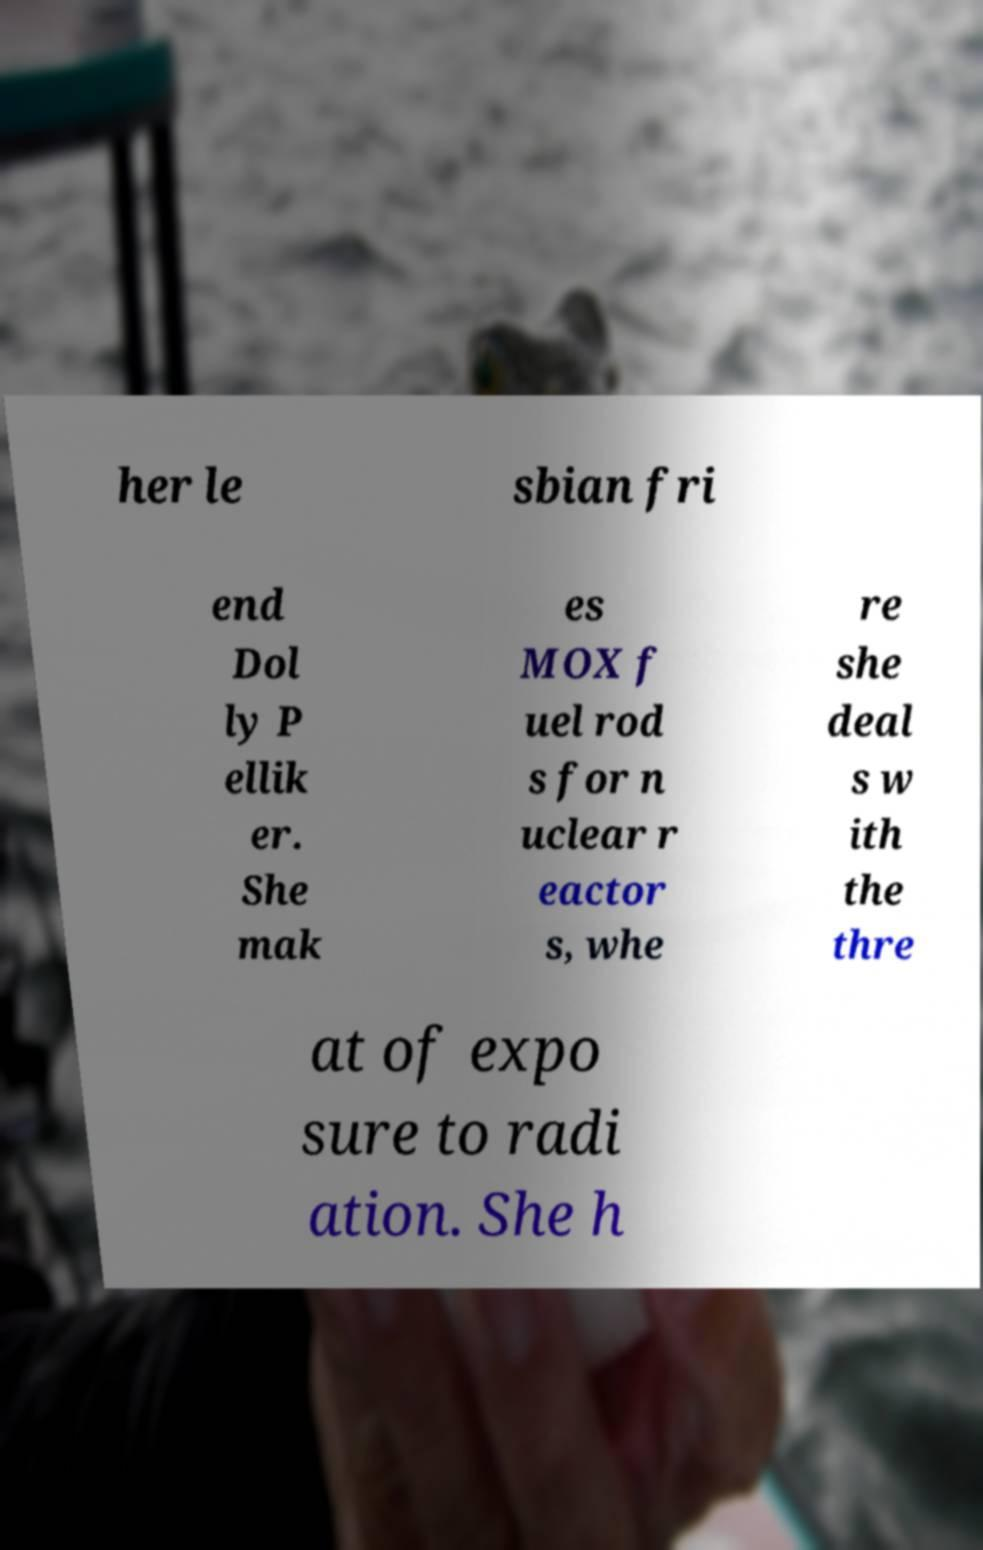Can you accurately transcribe the text from the provided image for me? her le sbian fri end Dol ly P ellik er. She mak es MOX f uel rod s for n uclear r eactor s, whe re she deal s w ith the thre at of expo sure to radi ation. She h 